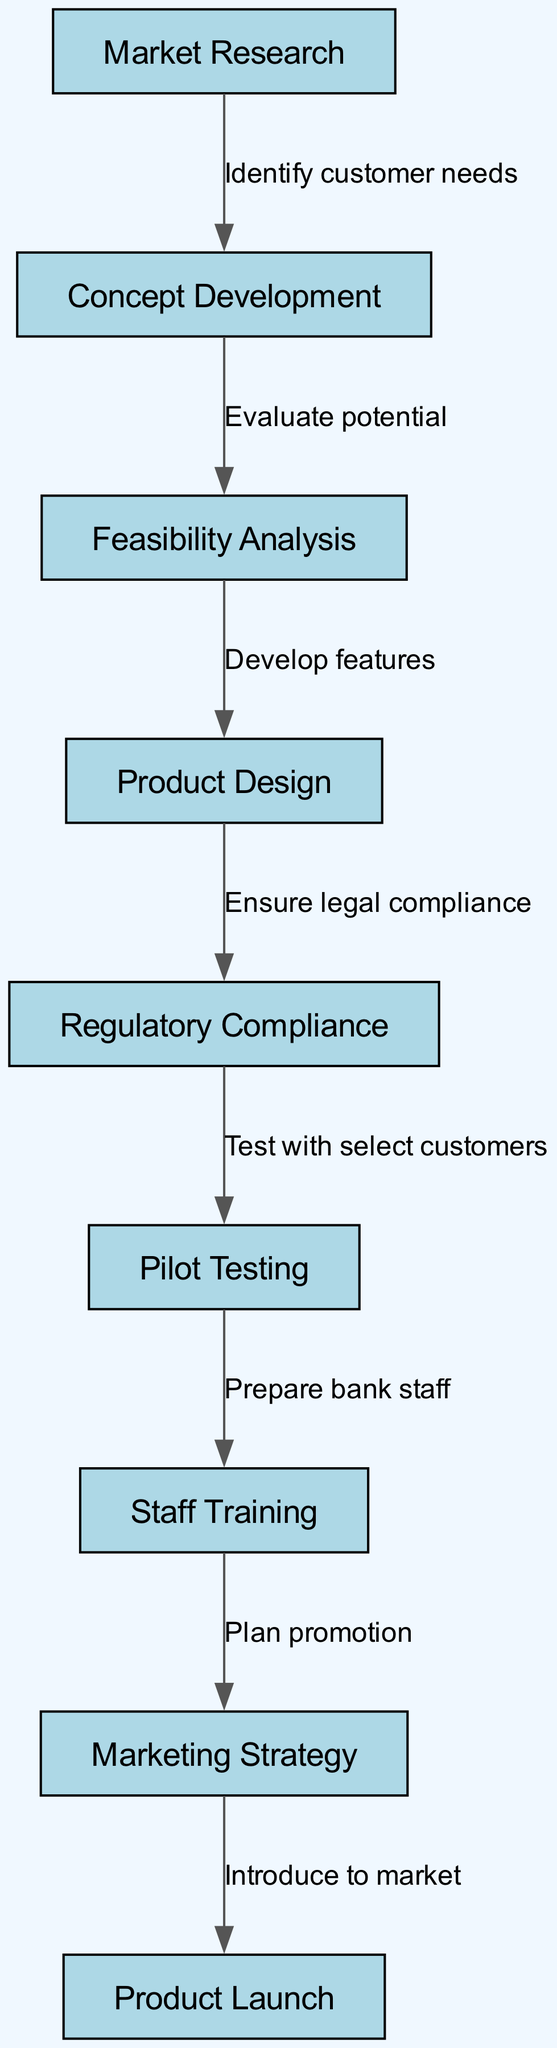What is the first stage in the product development lifecycle? The diagram starts with "Market Research" as the first node, indicating it is the initial stage in the development process.
Answer: Market Research How many total nodes are in the diagram? By counting each of the distinct stages represented by nodes in the diagram, there are nine nodes total.
Answer: 9 What node follows "Feasibility Analysis"? The diagram shows that "Product Design" immediately follows "Feasibility Analysis" as the next stage in the process.
Answer: Product Design What is the last step before "Product Launch"? "Marketing Strategy" is the node that comes just before "Product Launch" in the sequence, indicating preparation for the final introduction to the market.
Answer: Marketing Strategy What is the relationship between "Pilot Testing" and "Staff Training"? The diagram shows an arrow leading from "Pilot Testing" to "Staff Training," indicating that staff training occurs after pilot testing has been conducted.
Answer: Prepare bank staff List the stage that follows “Regulatory Compliance.” According to the diagram, "Pilot Testing" is the stage that follows "Regulatory Compliance," indicating that testing occurs after all regulatory checks are passed.
Answer: Pilot Testing What is the total number of edges in the diagram? By counting the directional connections (edges) between the nodes, the diagram contains eight edges connecting the stages of the process.
Answer: 8 Name the node that connects "Concept Development" and "Feasibility Analysis." The diagram portrays an edge from "Concept Development" to "Feasibility Analysis," answering that these two stages are directly connected in the process.
Answer: Evaluate potential 